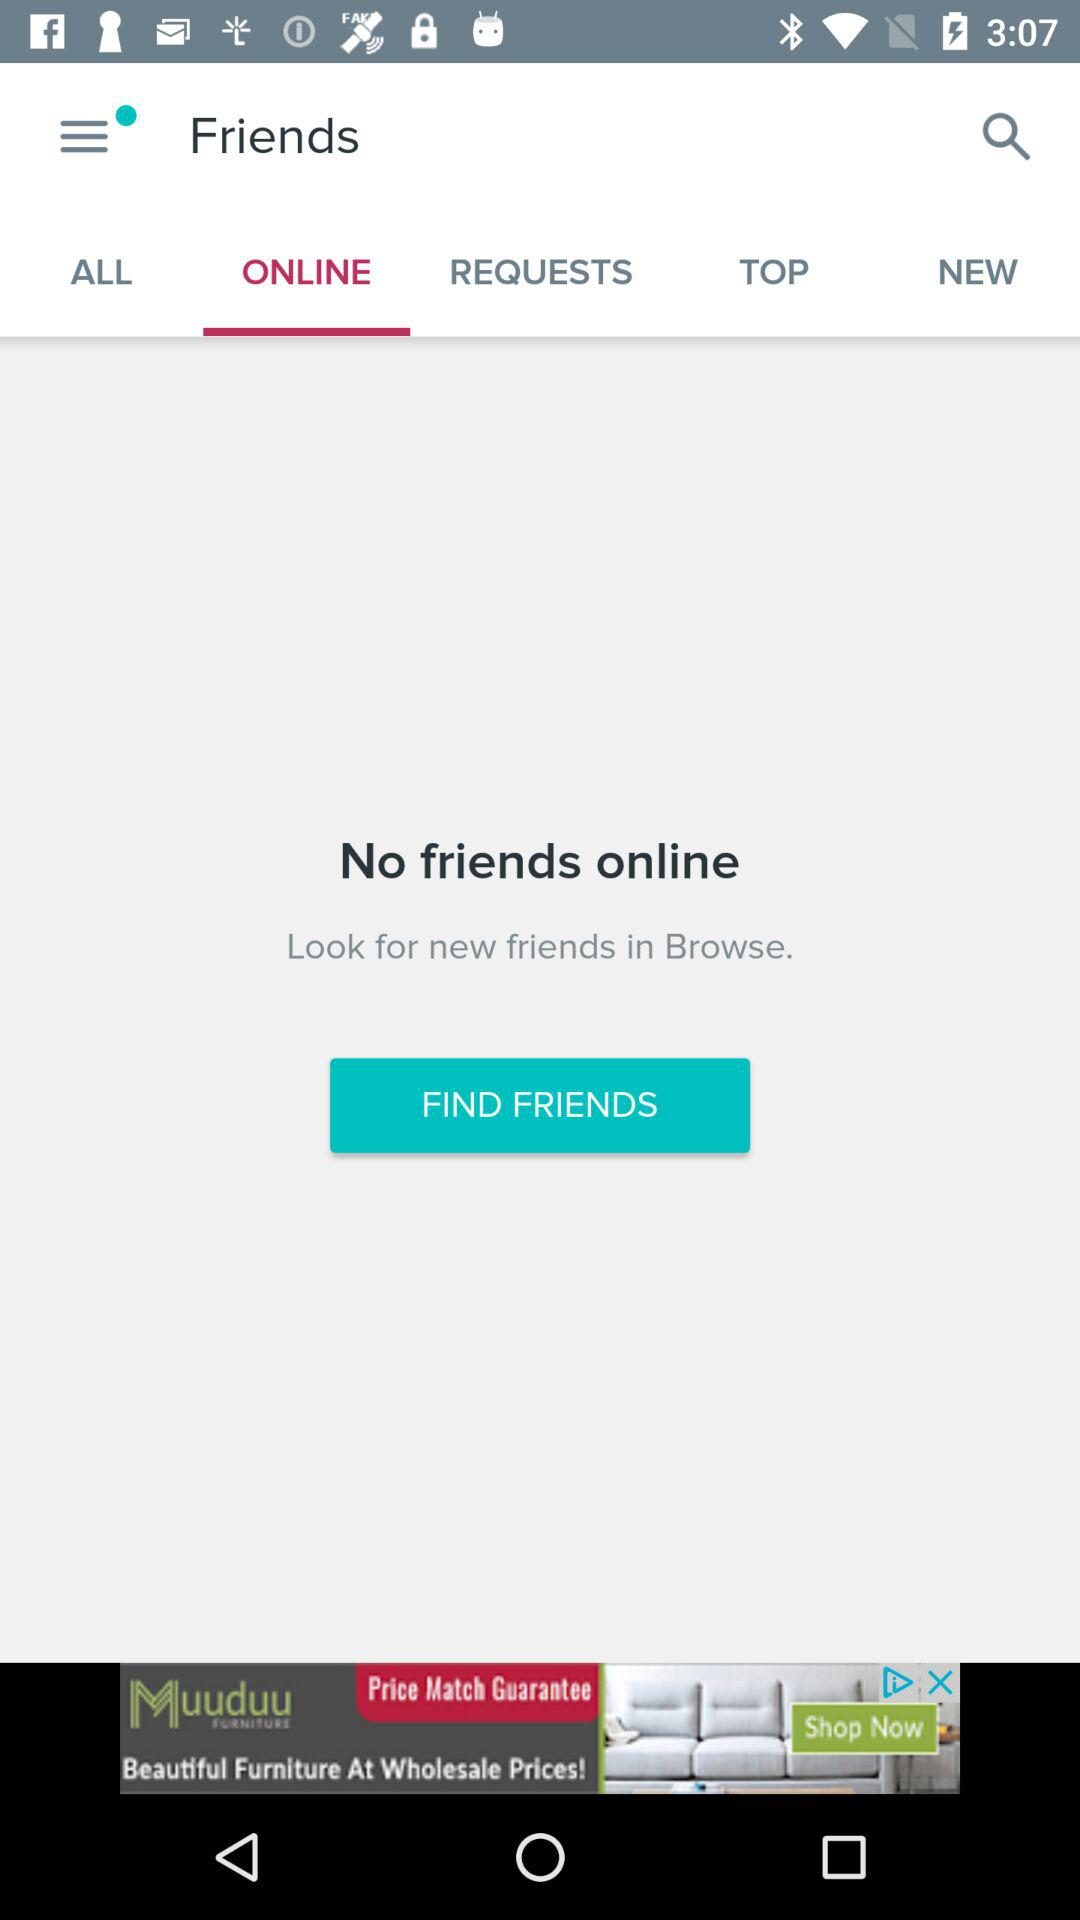Is there any friend online? There is no friend online. 